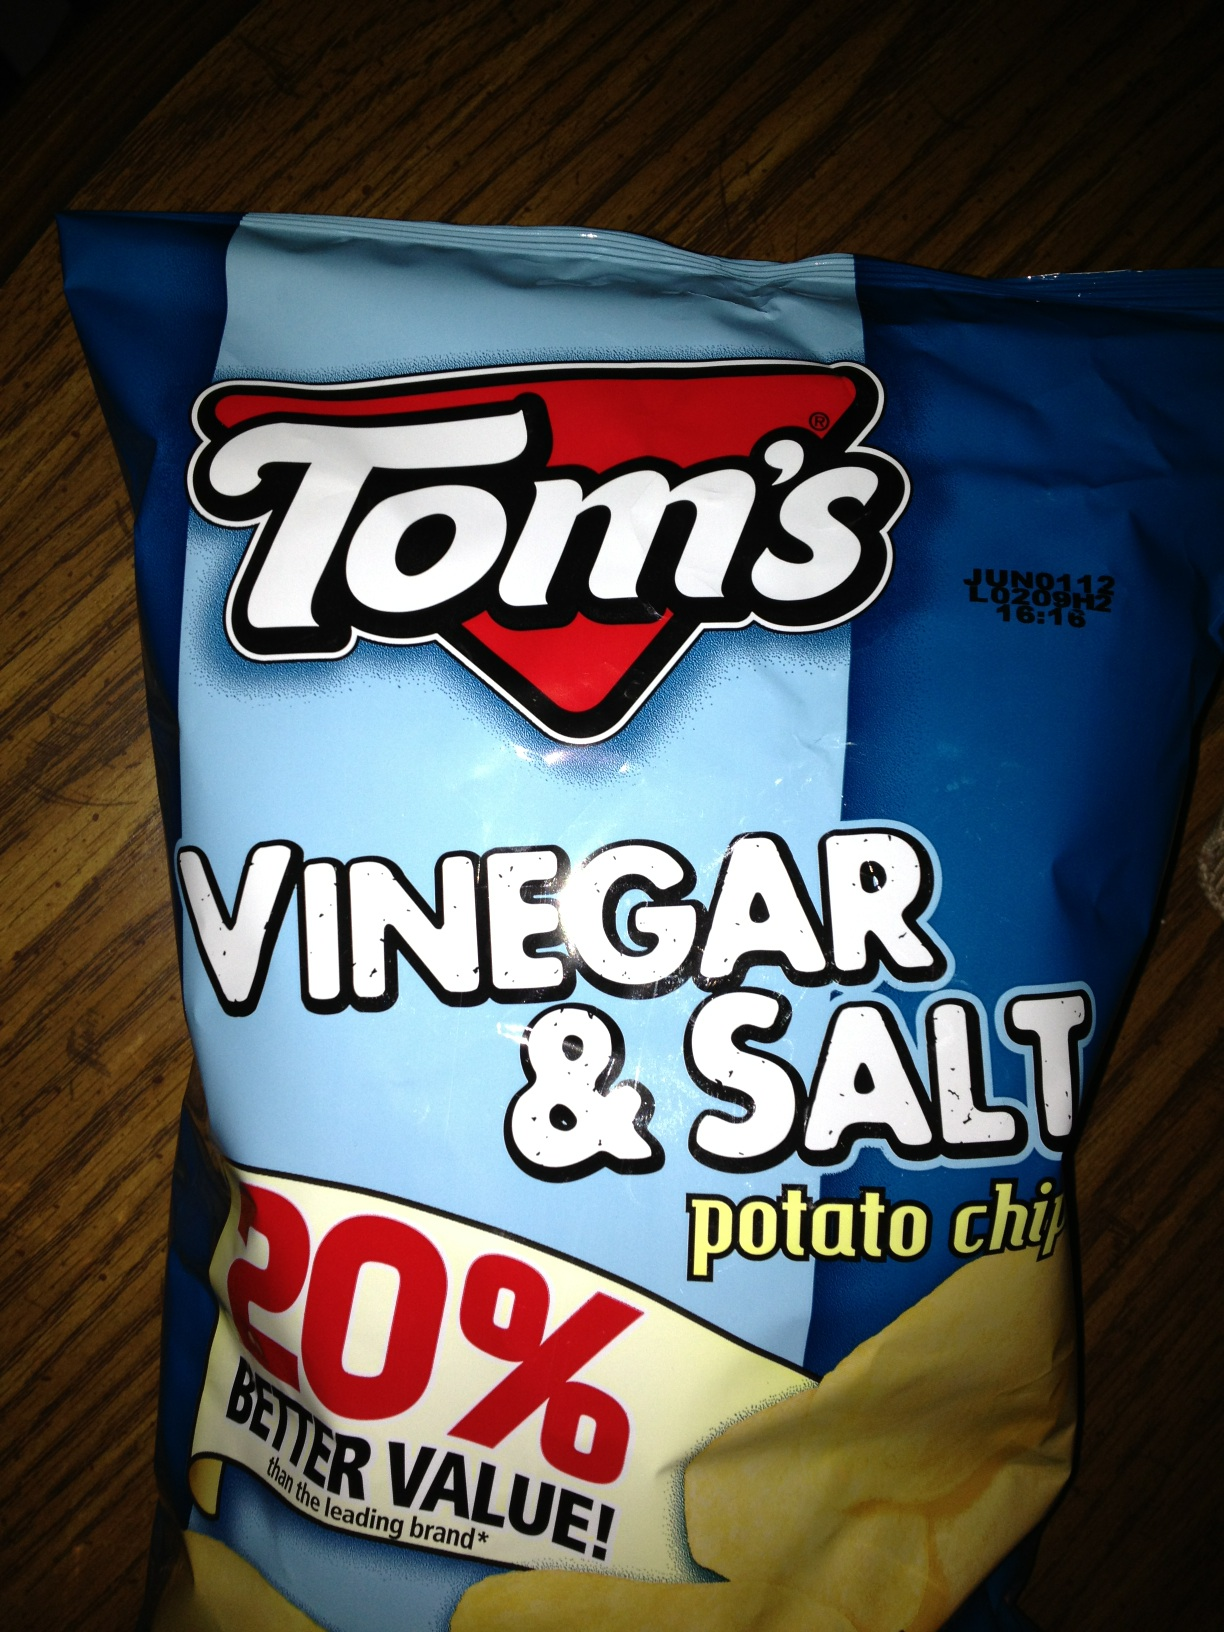What kind of chips are these? These are Tom's Vinegar & Salt potato chips, a tangy and savory snack that promises 20% better value than the leading brand. 